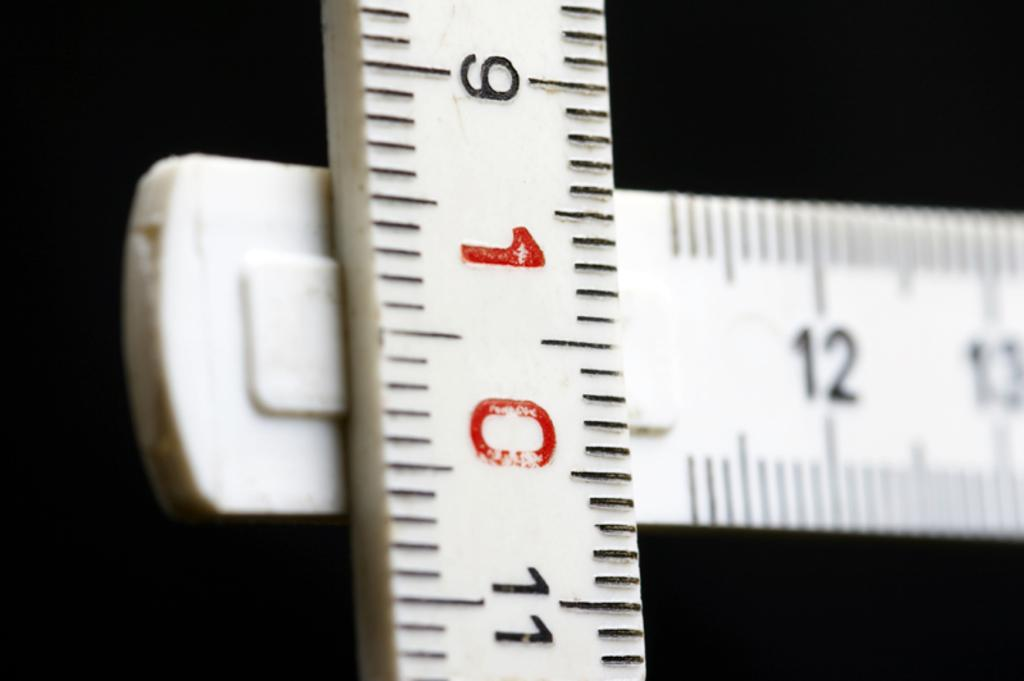<image>
Share a concise interpretation of the image provided. Two rulers are intersected with the top ruler has 10 in red. 